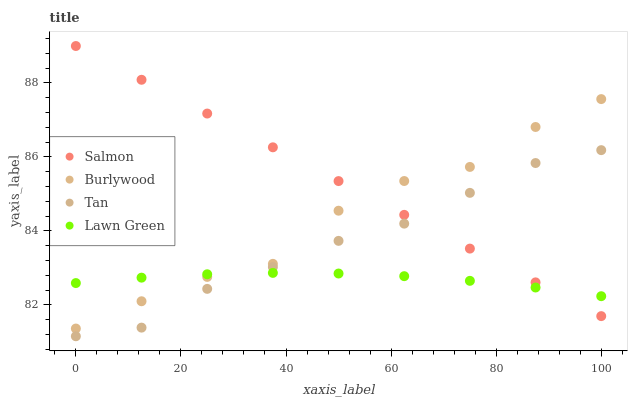Does Lawn Green have the minimum area under the curve?
Answer yes or no. Yes. Does Salmon have the maximum area under the curve?
Answer yes or no. Yes. Does Tan have the minimum area under the curve?
Answer yes or no. No. Does Tan have the maximum area under the curve?
Answer yes or no. No. Is Salmon the smoothest?
Answer yes or no. Yes. Is Burlywood the roughest?
Answer yes or no. Yes. Is Lawn Green the smoothest?
Answer yes or no. No. Is Lawn Green the roughest?
Answer yes or no. No. Does Tan have the lowest value?
Answer yes or no. Yes. Does Lawn Green have the lowest value?
Answer yes or no. No. Does Salmon have the highest value?
Answer yes or no. Yes. Does Tan have the highest value?
Answer yes or no. No. Is Tan less than Burlywood?
Answer yes or no. Yes. Is Burlywood greater than Tan?
Answer yes or no. Yes. Does Lawn Green intersect Tan?
Answer yes or no. Yes. Is Lawn Green less than Tan?
Answer yes or no. No. Is Lawn Green greater than Tan?
Answer yes or no. No. Does Tan intersect Burlywood?
Answer yes or no. No. 